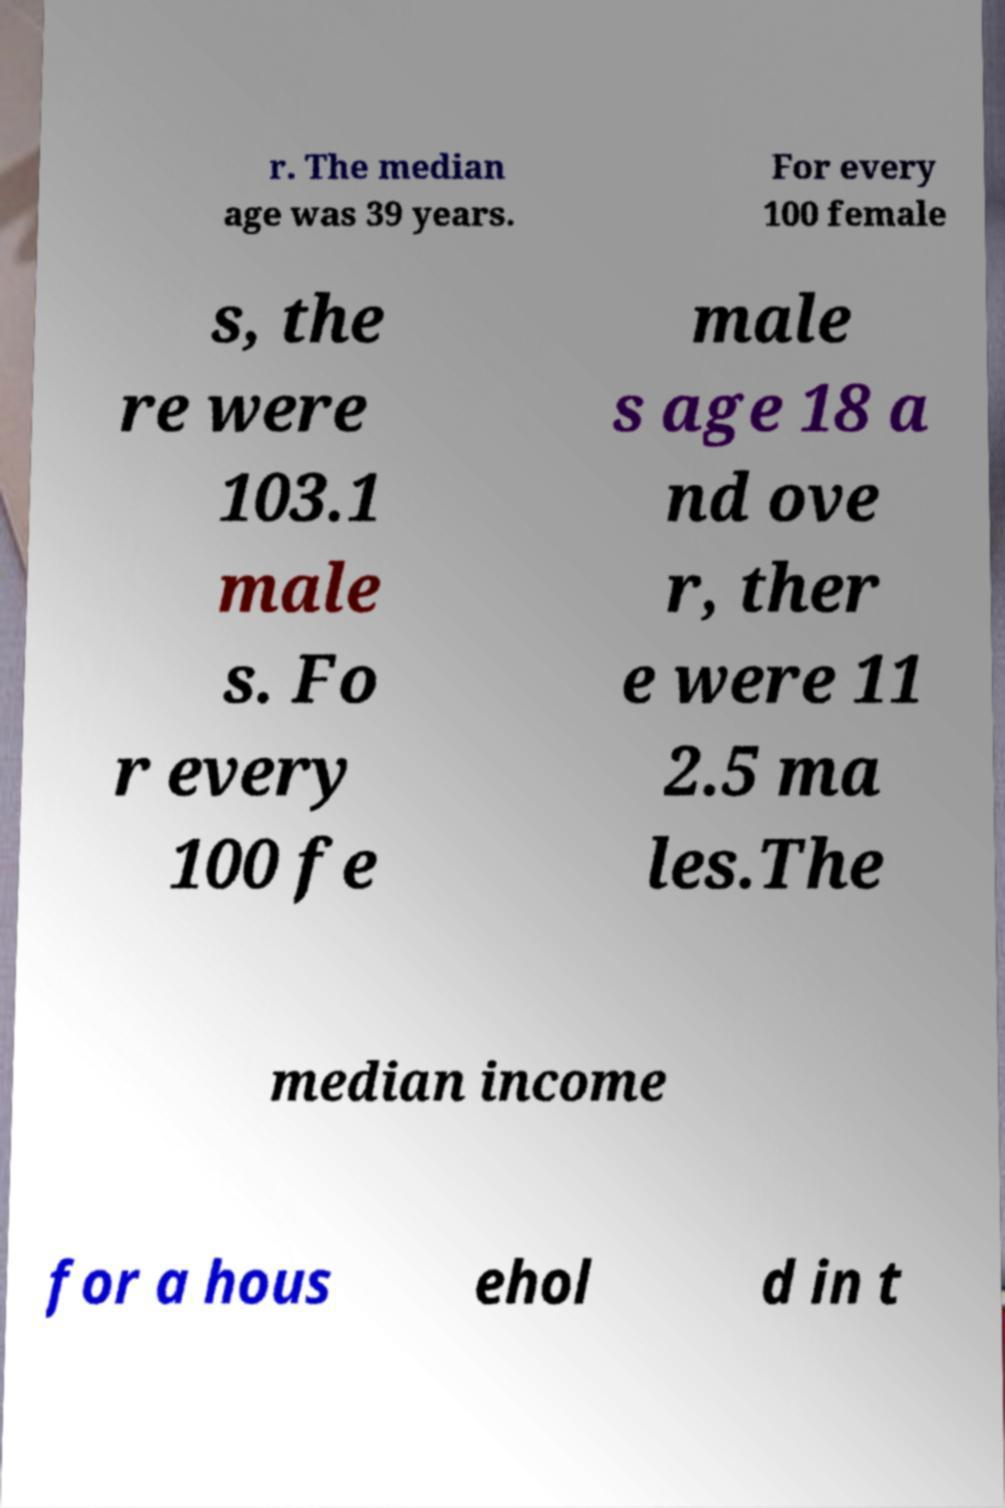Could you assist in decoding the text presented in this image and type it out clearly? r. The median age was 39 years. For every 100 female s, the re were 103.1 male s. Fo r every 100 fe male s age 18 a nd ove r, ther e were 11 2.5 ma les.The median income for a hous ehol d in t 